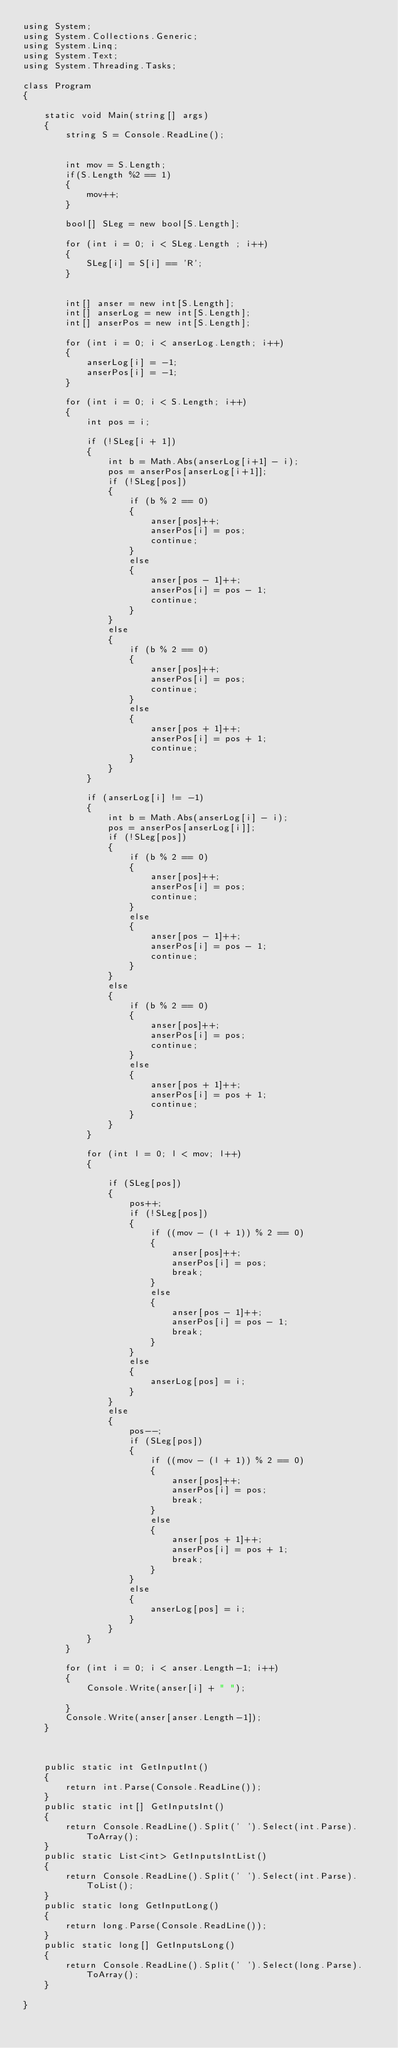<code> <loc_0><loc_0><loc_500><loc_500><_C#_>using System;
using System.Collections.Generic;
using System.Linq;
using System.Text;
using System.Threading.Tasks;

class Program
{

    static void Main(string[] args)
    {
        string S = Console.ReadLine();


        int mov = S.Length;
        if(S.Length %2 == 1)
        {
            mov++;
        }

        bool[] SLeg = new bool[S.Length];

        for (int i = 0; i < SLeg.Length ; i++)
        {
            SLeg[i] = S[i] == 'R';
        }


        int[] anser = new int[S.Length];
        int[] anserLog = new int[S.Length];
        int[] anserPos = new int[S.Length];

        for (int i = 0; i < anserLog.Length; i++)
        {
            anserLog[i] = -1;
            anserPos[i] = -1;
        }

        for (int i = 0; i < S.Length; i++)
        {
            int pos = i;

            if (!SLeg[i + 1])
            {
                int b = Math.Abs(anserLog[i+1] - i);
                pos = anserPos[anserLog[i+1]];
                if (!SLeg[pos])
                {
                    if (b % 2 == 0)
                    {
                        anser[pos]++;
                        anserPos[i] = pos;
                        continue;
                    }
                    else
                    {
                        anser[pos - 1]++;
                        anserPos[i] = pos - 1;
                        continue;
                    }
                }
                else
                {
                    if (b % 2 == 0)
                    {
                        anser[pos]++;
                        anserPos[i] = pos;
                        continue;
                    }
                    else
                    {
                        anser[pos + 1]++;
                        anserPos[i] = pos + 1;
                        continue;
                    }
                }
            }

            if (anserLog[i] != -1)
            {
                int b = Math.Abs(anserLog[i] - i);
                pos = anserPos[anserLog[i]];
                if (!SLeg[pos])
                {
                    if (b % 2 == 0)
                    {
                        anser[pos]++;
                        anserPos[i] = pos;
                        continue;
                    }
                    else
                    {
                        anser[pos - 1]++;
                        anserPos[i] = pos - 1;
                        continue;
                    }
                }
                else
                {
                    if (b % 2 == 0)
                    {
                        anser[pos]++;
                        anserPos[i] = pos;
                        continue;
                    }
                    else
                    {
                        anser[pos + 1]++;
                        anserPos[i] = pos + 1;
                        continue;
                    }
                }
            }

            for (int l = 0; l < mov; l++)
            {

                if (SLeg[pos])
                {
                    pos++;
                    if (!SLeg[pos])
                    {
                        if ((mov - (l + 1)) % 2 == 0)
                        {
                            anser[pos]++;
                            anserPos[i] = pos;
                            break;
                        }
                        else
                        {
                            anser[pos - 1]++;
                            anserPos[i] = pos - 1;
                            break;
                        }
                    }
                    else
                    {
                        anserLog[pos] = i;
                    }
                }
                else
                {
                    pos--;
                    if (SLeg[pos])
                    {
                        if ((mov - (l + 1)) % 2 == 0)
                        {
                            anser[pos]++;
                            anserPos[i] = pos;
                            break;
                        }
                        else
                        {
                            anser[pos + 1]++;
                            anserPos[i] = pos + 1;
                            break;
                        }
                    }
                    else
                    {
                        anserLog[pos] = i;
                    }
                }
            }
        }

        for (int i = 0; i < anser.Length-1; i++)
        {
            Console.Write(anser[i] + " ");

        }
        Console.Write(anser[anser.Length-1]);
    }



    public static int GetInputInt()
    {
        return int.Parse(Console.ReadLine());
    }
    public static int[] GetInputsInt()
    {
        return Console.ReadLine().Split(' ').Select(int.Parse).ToArray();
    }
    public static List<int> GetInputsIntList()
    {
        return Console.ReadLine().Split(' ').Select(int.Parse).ToList();
    }
    public static long GetInputLong()
    {
        return long.Parse(Console.ReadLine());
    }
    public static long[] GetInputsLong()
    {
        return Console.ReadLine().Split(' ').Select(long.Parse).ToArray();
    }

}
</code> 